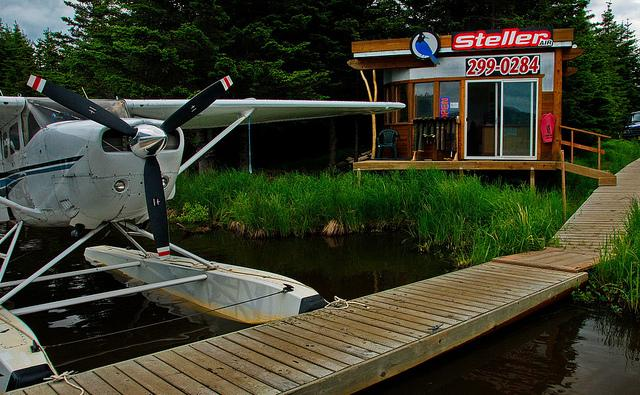What rhymes with the name of the store and is found on the vehicle? Please explain your reasoning. propeller. The only word that can be the possible answer is "a" when it comes to rhyming. 